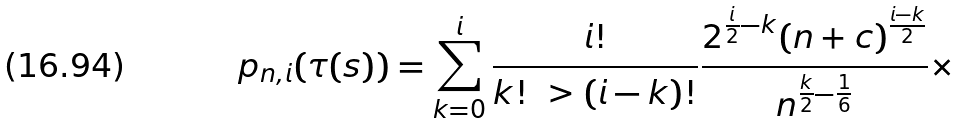Convert formula to latex. <formula><loc_0><loc_0><loc_500><loc_500>p _ { n , i } ( \tau ( s ) ) = \sum _ { k = 0 } ^ { i } \frac { i ! } { k ! \ > ( i - k ) ! } \frac { 2 ^ { \frac { i } { 2 } - k } ( n + c ) ^ { \frac { i - k } { 2 } } } { n ^ { \frac { k } { 2 } - \frac { 1 } { 6 } } } \times</formula> 